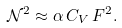<formula> <loc_0><loc_0><loc_500><loc_500>\mathcal { N } ^ { 2 } \approx \alpha \, C _ { V } \, F ^ { 2 } .</formula> 